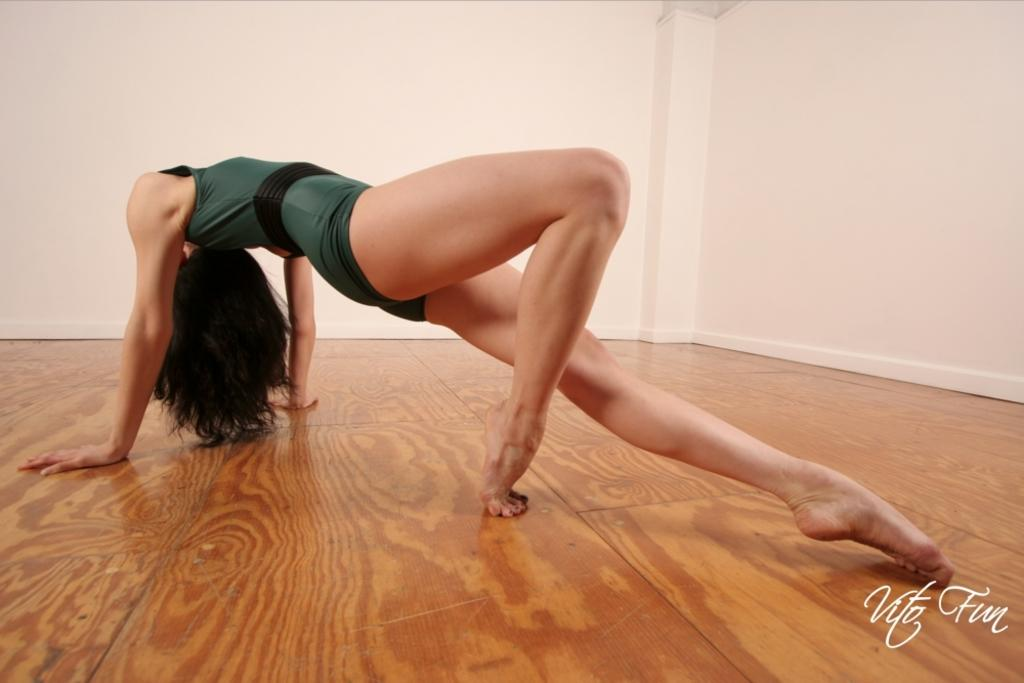Who or what is present in the image? There is a person in the image. What is the person wearing? The person is wearing a green and black dress. What is the color of the surface the person is standing on? The person is on a brown colored surface. What can be seen in the background of the image? There is a white colored wall in the background of the image. What type of news can be heard from the wren in the image? There is no wren present in the image, and therefore no news can be heard from it. 